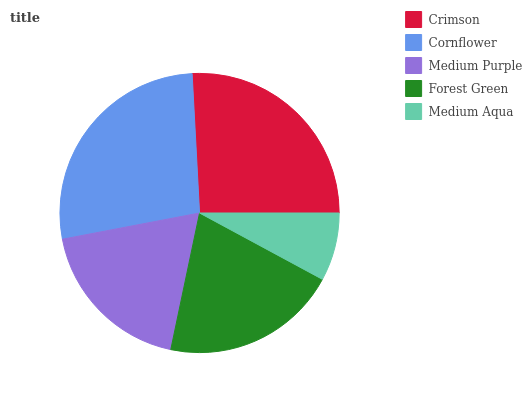Is Medium Aqua the minimum?
Answer yes or no. Yes. Is Cornflower the maximum?
Answer yes or no. Yes. Is Medium Purple the minimum?
Answer yes or no. No. Is Medium Purple the maximum?
Answer yes or no. No. Is Cornflower greater than Medium Purple?
Answer yes or no. Yes. Is Medium Purple less than Cornflower?
Answer yes or no. Yes. Is Medium Purple greater than Cornflower?
Answer yes or no. No. Is Cornflower less than Medium Purple?
Answer yes or no. No. Is Forest Green the high median?
Answer yes or no. Yes. Is Forest Green the low median?
Answer yes or no. Yes. Is Medium Aqua the high median?
Answer yes or no. No. Is Crimson the low median?
Answer yes or no. No. 